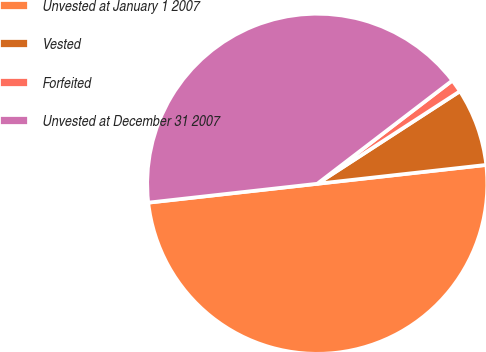<chart> <loc_0><loc_0><loc_500><loc_500><pie_chart><fcel>Unvested at January 1 2007<fcel>Vested<fcel>Forfeited<fcel>Unvested at December 31 2007<nl><fcel>50.0%<fcel>7.39%<fcel>1.23%<fcel>41.38%<nl></chart> 